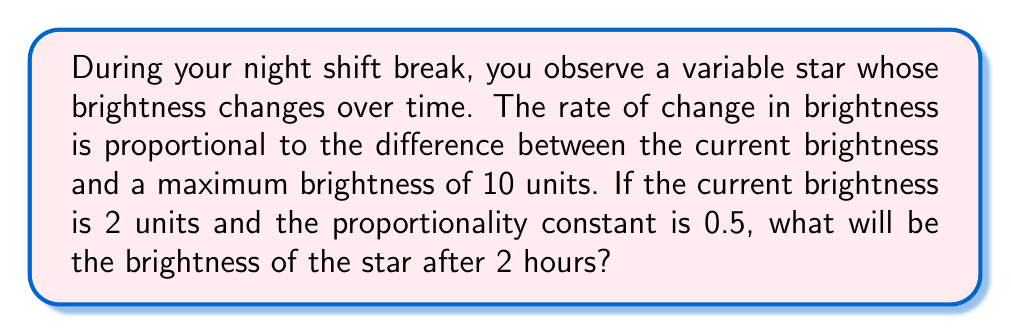Could you help me with this problem? Let's approach this step-by-step:

1) Let $B(t)$ be the brightness of the star at time $t$ (in hours).

2) Given information:
   - Maximum brightness: $B_{max} = 10$ units
   - Initial brightness: $B(0) = 2$ units
   - Proportionality constant: $k = 0.5$

3) The rate of change in brightness is proportional to the difference between the maximum brightness and the current brightness. This can be expressed as a differential equation:

   $$\frac{dB}{dt} = k(B_{max} - B)$$

4) Substituting the given values:

   $$\frac{dB}{dt} = 0.5(10 - B)$$

5) This is a separable differential equation. Let's solve it:

   $$\frac{dB}{10 - B} = 0.5dt$$

6) Integrating both sides:

   $$-\ln|10 - B| = 0.5t + C$$

7) Using the initial condition $B(0) = 2$:

   $$-\ln|10 - 2| = C$$
   $$C = -\ln(8)$$

8) Substituting back:

   $$-\ln|10 - B| = 0.5t - \ln(8)$$

9) Solving for $B$:

   $$\ln|10 - B| = \ln(8) - 0.5t$$
   $$|10 - B| = 8e^{-0.5t}$$
   $$10 - B = 8e^{-0.5t}$$
   $$B = 10 - 8e^{-0.5t}$$

10) To find the brightness after 2 hours, substitute $t = 2$:

    $$B(2) = 10 - 8e^{-0.5(2)} = 10 - 8e^{-1} \approx 7.06$$

Therefore, after 2 hours, the brightness of the star will be approximately 7.06 units.
Answer: $B(2) \approx 7.06$ units 